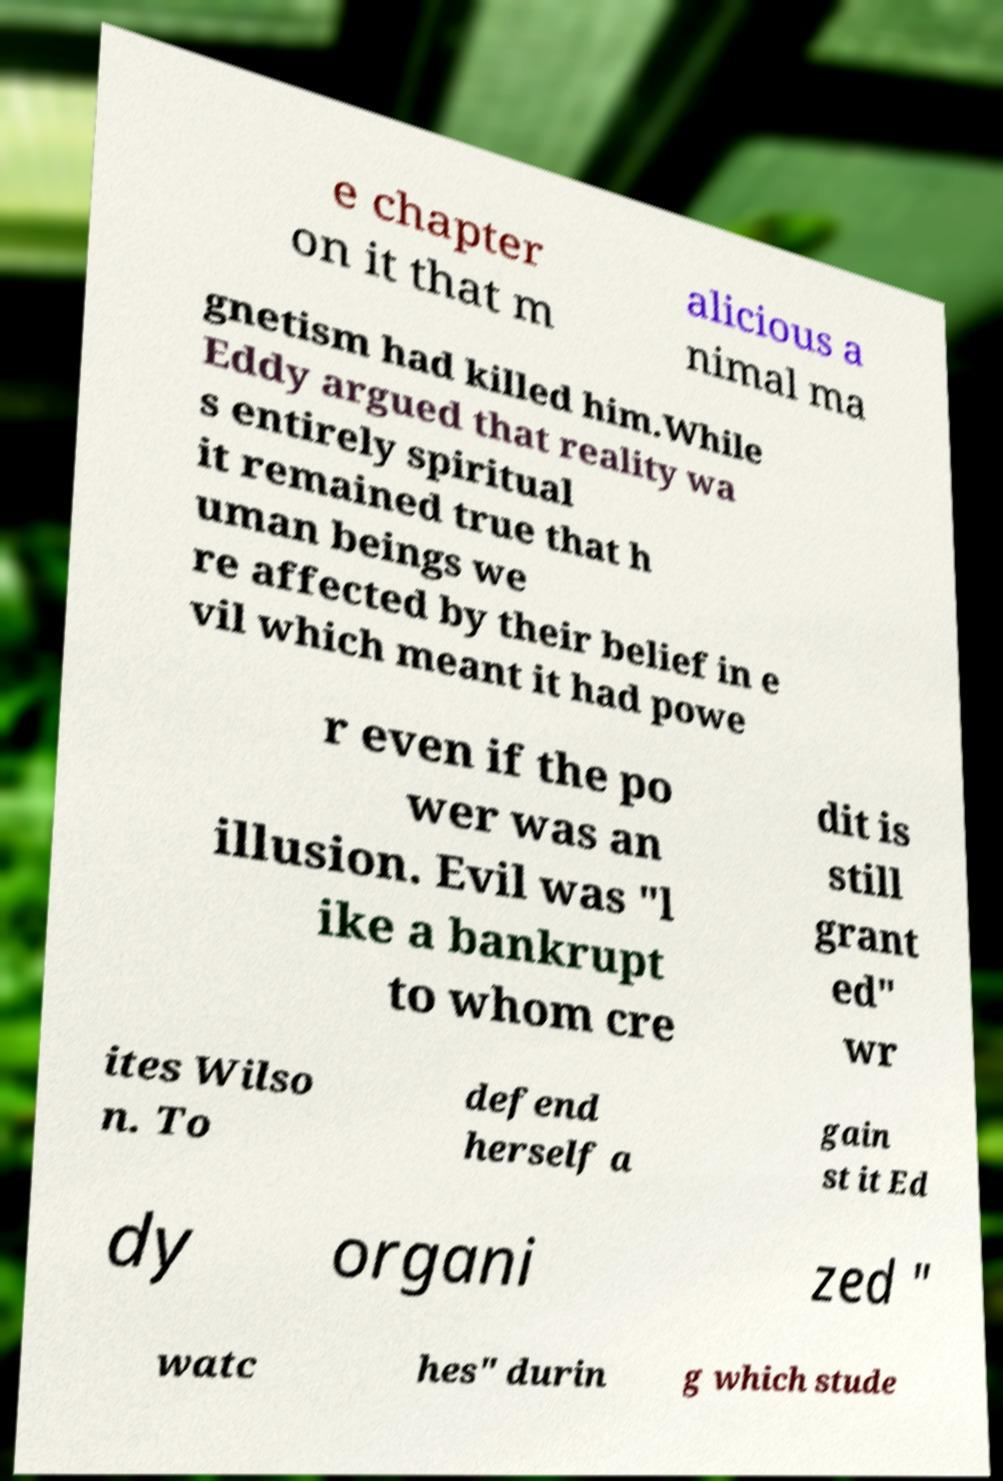I need the written content from this picture converted into text. Can you do that? e chapter on it that m alicious a nimal ma gnetism had killed him.While Eddy argued that reality wa s entirely spiritual it remained true that h uman beings we re affected by their belief in e vil which meant it had powe r even if the po wer was an illusion. Evil was "l ike a bankrupt to whom cre dit is still grant ed" wr ites Wilso n. To defend herself a gain st it Ed dy organi zed " watc hes" durin g which stude 